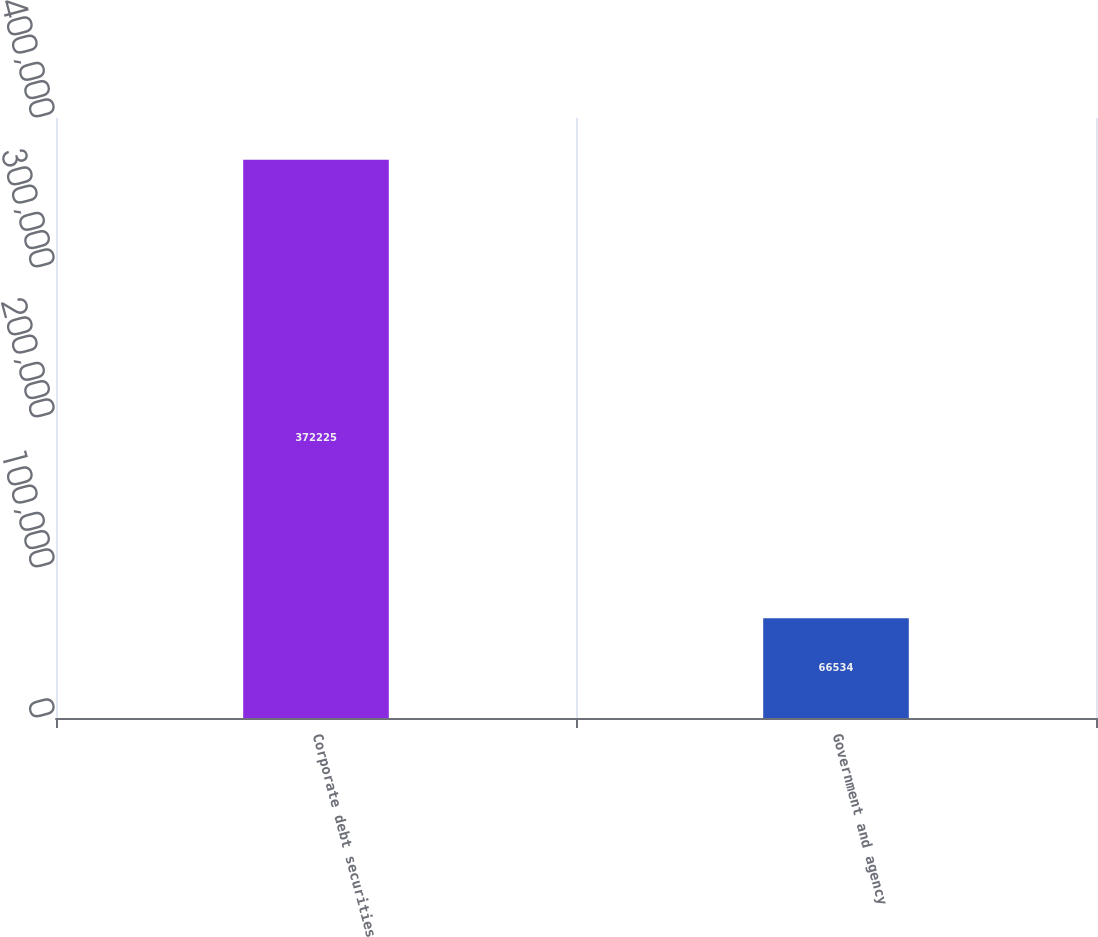<chart> <loc_0><loc_0><loc_500><loc_500><bar_chart><fcel>Corporate debt securities<fcel>Government and agency<nl><fcel>372225<fcel>66534<nl></chart> 